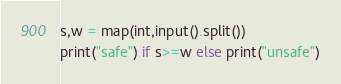<code> <loc_0><loc_0><loc_500><loc_500><_Python_>s,w = map(int,input().split())
print("safe") if s>=w else print("unsafe")
</code> 